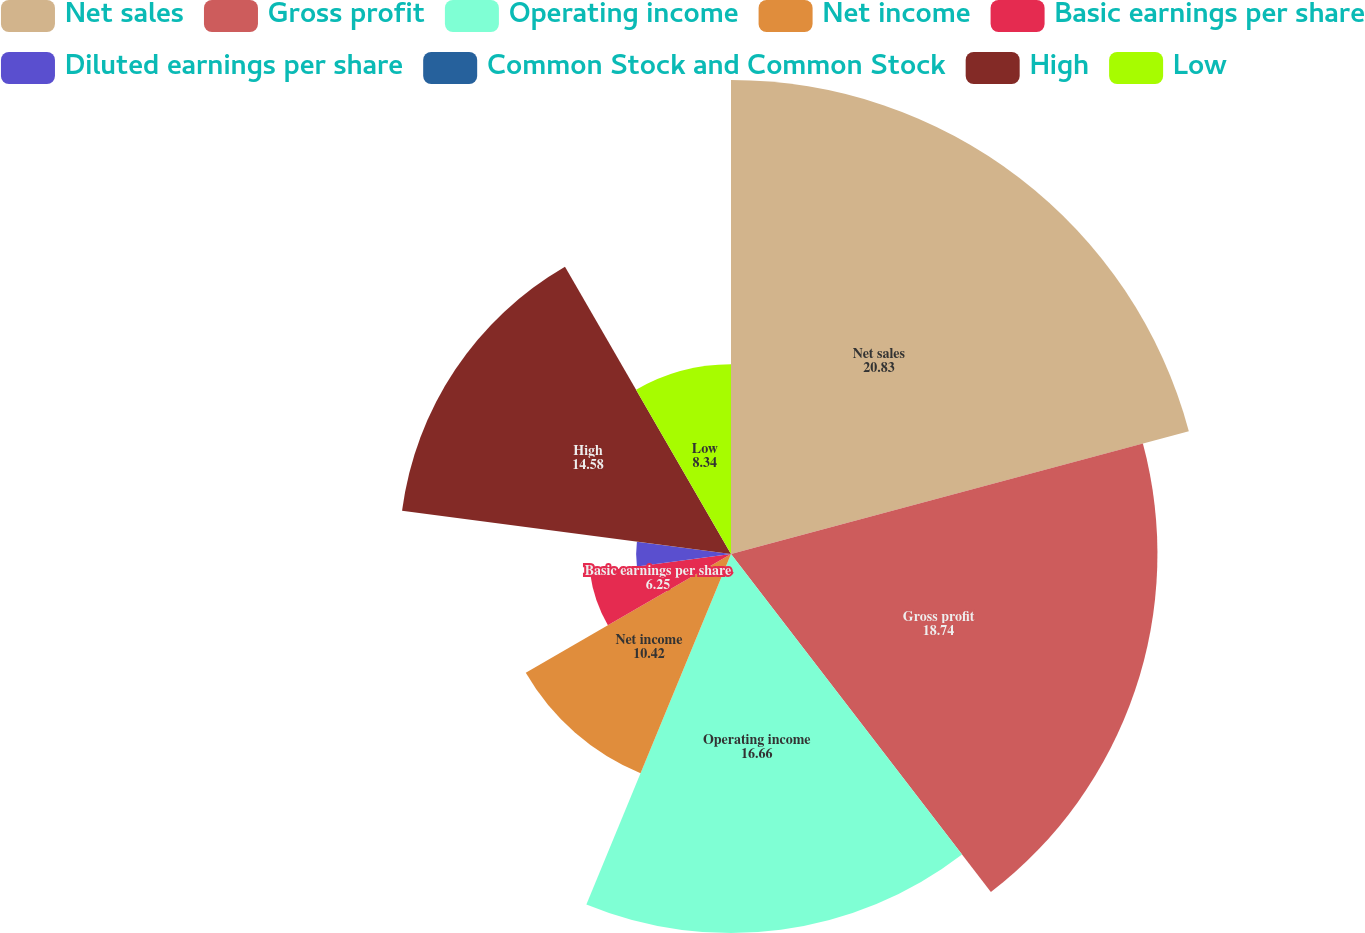<chart> <loc_0><loc_0><loc_500><loc_500><pie_chart><fcel>Net sales<fcel>Gross profit<fcel>Operating income<fcel>Net income<fcel>Basic earnings per share<fcel>Diluted earnings per share<fcel>Common Stock and Common Stock<fcel>High<fcel>Low<nl><fcel>20.83%<fcel>18.74%<fcel>16.66%<fcel>10.42%<fcel>6.25%<fcel>4.17%<fcel>0.01%<fcel>14.58%<fcel>8.34%<nl></chart> 